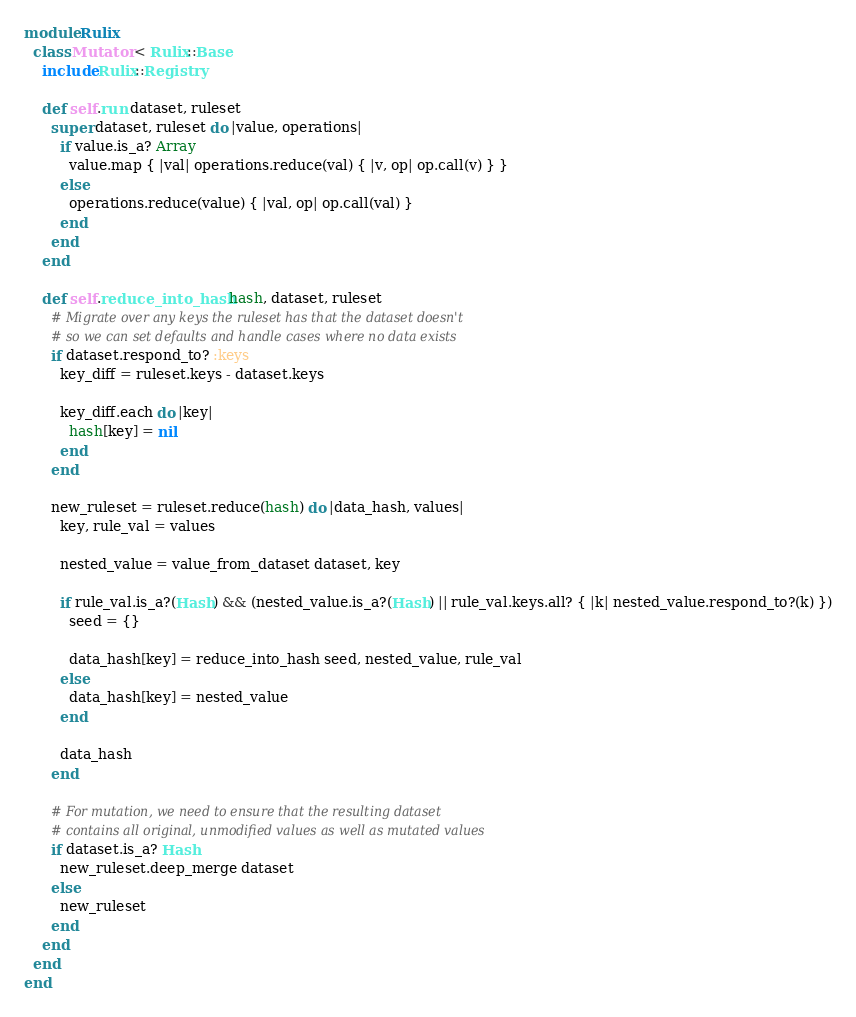Convert code to text. <code><loc_0><loc_0><loc_500><loc_500><_Ruby_>module Rulix
  class Mutator < Rulix::Base
    include Rulix::Registry

    def self.run dataset, ruleset
      super dataset, ruleset do |value, operations|
        if value.is_a? Array
          value.map { |val| operations.reduce(val) { |v, op| op.call(v) } }
        else
          operations.reduce(value) { |val, op| op.call(val) }
        end
      end
    end

    def self.reduce_into_hash hash, dataset, ruleset
      # Migrate over any keys the ruleset has that the dataset doesn't
      # so we can set defaults and handle cases where no data exists
      if dataset.respond_to? :keys
        key_diff = ruleset.keys - dataset.keys

        key_diff.each do |key|
          hash[key] = nil
        end
      end

      new_ruleset = ruleset.reduce(hash) do |data_hash, values|
        key, rule_val = values

        nested_value = value_from_dataset dataset, key

        if rule_val.is_a?(Hash) && (nested_value.is_a?(Hash) || rule_val.keys.all? { |k| nested_value.respond_to?(k) })
          seed = {}

          data_hash[key] = reduce_into_hash seed, nested_value, rule_val
        else
          data_hash[key] = nested_value
        end

        data_hash
      end

      # For mutation, we need to ensure that the resulting dataset
      # contains all original, unmodified values as well as mutated values
      if dataset.is_a? Hash
        new_ruleset.deep_merge dataset
      else
        new_ruleset
      end
    end
  end
end</code> 